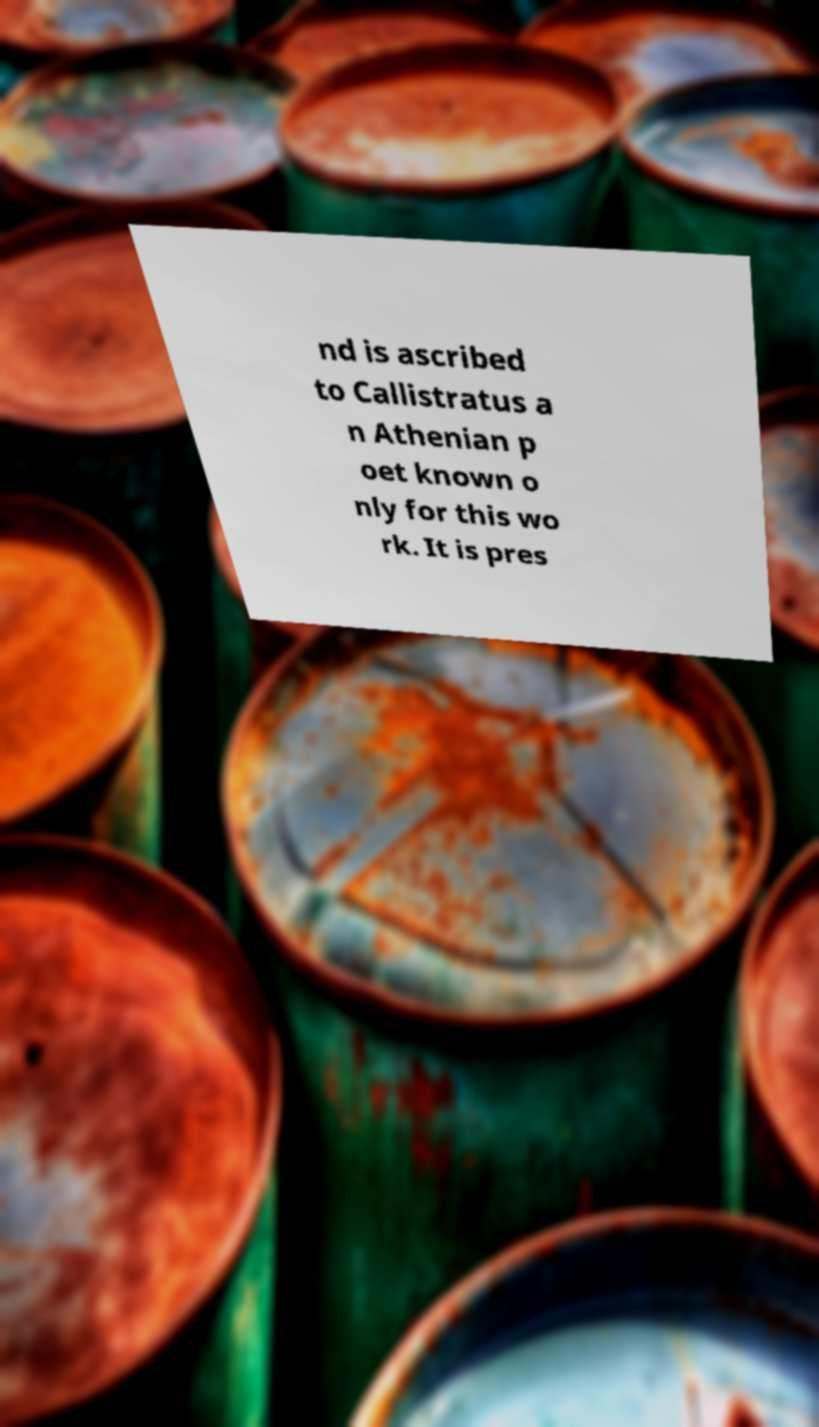For documentation purposes, I need the text within this image transcribed. Could you provide that? nd is ascribed to Callistratus a n Athenian p oet known o nly for this wo rk. It is pres 